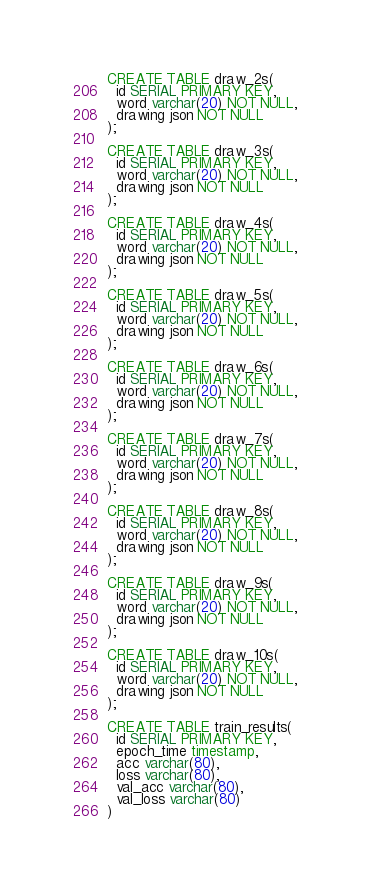<code> <loc_0><loc_0><loc_500><loc_500><_SQL_>CREATE TABLE draw_2s(
  id SERIAL PRIMARY KEY,
  word varchar(20) NOT NULL,
  drawing json NOT NULL
);

CREATE TABLE draw_3s(
  id SERIAL PRIMARY KEY,
  word varchar(20) NOT NULL,
  drawing json NOT NULL
);

CREATE TABLE draw_4s(
  id SERIAL PRIMARY KEY,
  word varchar(20) NOT NULL,
  drawing json NOT NULL
);

CREATE TABLE draw_5s(
  id SERIAL PRIMARY KEY,
  word varchar(20) NOT NULL,
  drawing json NOT NULL
);

CREATE TABLE draw_6s(
  id SERIAL PRIMARY KEY,
  word varchar(20) NOT NULL,
  drawing json NOT NULL
);

CREATE TABLE draw_7s(
  id SERIAL PRIMARY KEY,
  word varchar(20) NOT NULL,
  drawing json NOT NULL
);

CREATE TABLE draw_8s(
  id SERIAL PRIMARY KEY,
  word varchar(20) NOT NULL,
  drawing json NOT NULL
);

CREATE TABLE draw_9s(
  id SERIAL PRIMARY KEY,
  word varchar(20) NOT NULL,
  drawing json NOT NULL
);

CREATE TABLE draw_10s(
  id SERIAL PRIMARY KEY,
  word varchar(20) NOT NULL,
  drawing json NOT NULL
);

CREATE TABLE train_results(
  id SERIAL PRIMARY KEY,
  epoch_time timestamp,
  acc varchar(80),
  loss varchar(80),
  val_acc varchar(80),
  val_loss varchar(80)
)</code> 